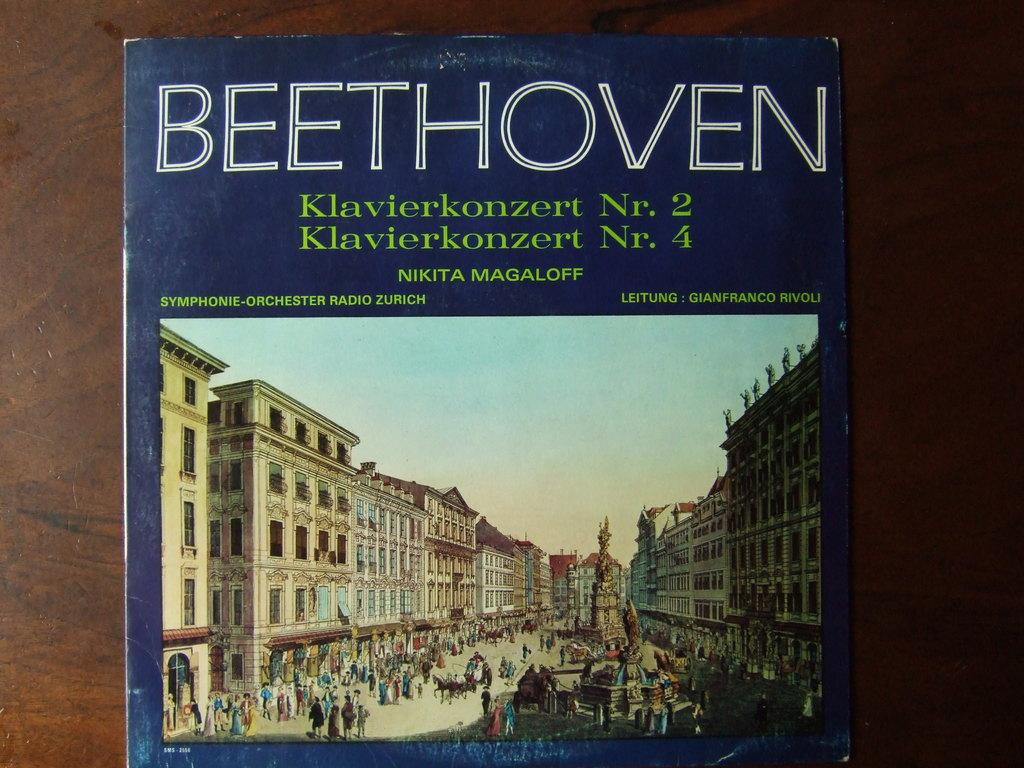<image>
Create a compact narrative representing the image presented. a record cover for beethoven klavierkonzert nr. 2 